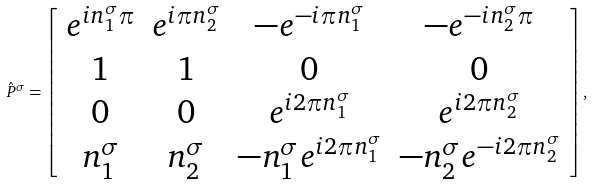<formula> <loc_0><loc_0><loc_500><loc_500>\hat { P } ^ { \sigma } = \left [ \begin{array} { c c c c } e ^ { i n _ { 1 } ^ { \sigma } \pi } & e ^ { i \pi n _ { 2 } ^ { \sigma } } & - e ^ { - i \pi n _ { 1 } ^ { \sigma } } & - e ^ { - i n _ { 2 } ^ { \sigma } \pi } \\ 1 & 1 & 0 & 0 \\ 0 & 0 & e ^ { i 2 \pi n _ { 1 } ^ { \sigma } } & e ^ { i 2 \pi n _ { 2 } ^ { \sigma } } \\ n _ { 1 } ^ { \sigma } & n _ { 2 } ^ { \sigma } & - n _ { 1 } ^ { \sigma } e ^ { i 2 \pi n _ { 1 } ^ { \sigma } } & - n _ { 2 } ^ { \sigma } e ^ { - i 2 \pi n _ { 2 } ^ { \sigma } } \end{array} \right ] ,</formula> 